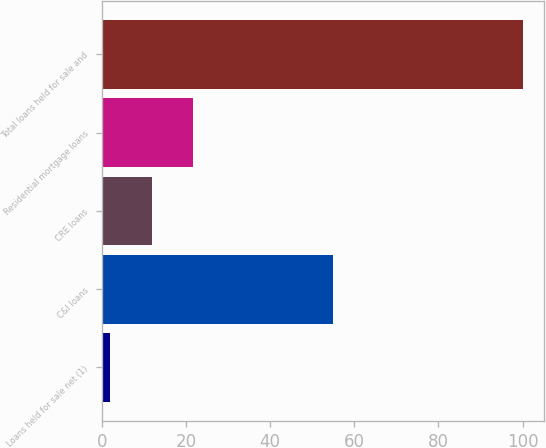<chart> <loc_0><loc_0><loc_500><loc_500><bar_chart><fcel>Loans held for sale net (1)<fcel>C&I loans<fcel>CRE loans<fcel>Residential mortgage loans<fcel>Total loans held for sale and<nl><fcel>2<fcel>55<fcel>11.8<fcel>21.6<fcel>100<nl></chart> 